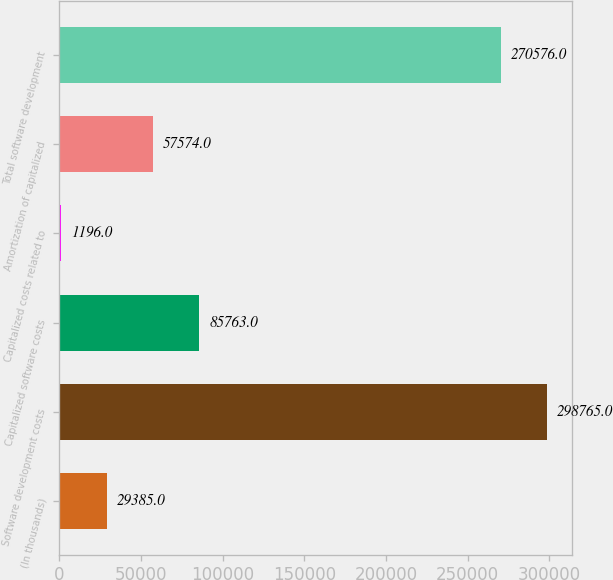Convert chart to OTSL. <chart><loc_0><loc_0><loc_500><loc_500><bar_chart><fcel>(In thousands)<fcel>Software development costs<fcel>Capitalized software costs<fcel>Capitalized costs related to<fcel>Amortization of capitalized<fcel>Total software development<nl><fcel>29385<fcel>298765<fcel>85763<fcel>1196<fcel>57574<fcel>270576<nl></chart> 